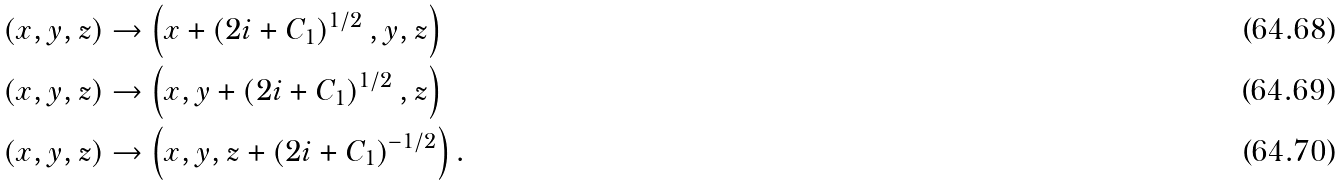<formula> <loc_0><loc_0><loc_500><loc_500>\left ( x , y , z \right ) & \rightarrow \left ( x + \left ( 2 i + C _ { 1 } \right ) ^ { 1 / 2 } , y , z \right ) \\ \left ( x , y , z \right ) & \rightarrow \left ( x , y + \left ( 2 i + C _ { 1 } \right ) ^ { 1 / 2 } , z \right ) \\ \left ( x , y , z \right ) & \rightarrow \left ( x , y , z + \left ( 2 i + C _ { 1 } \right ) ^ { - 1 / 2 } \right ) .</formula> 